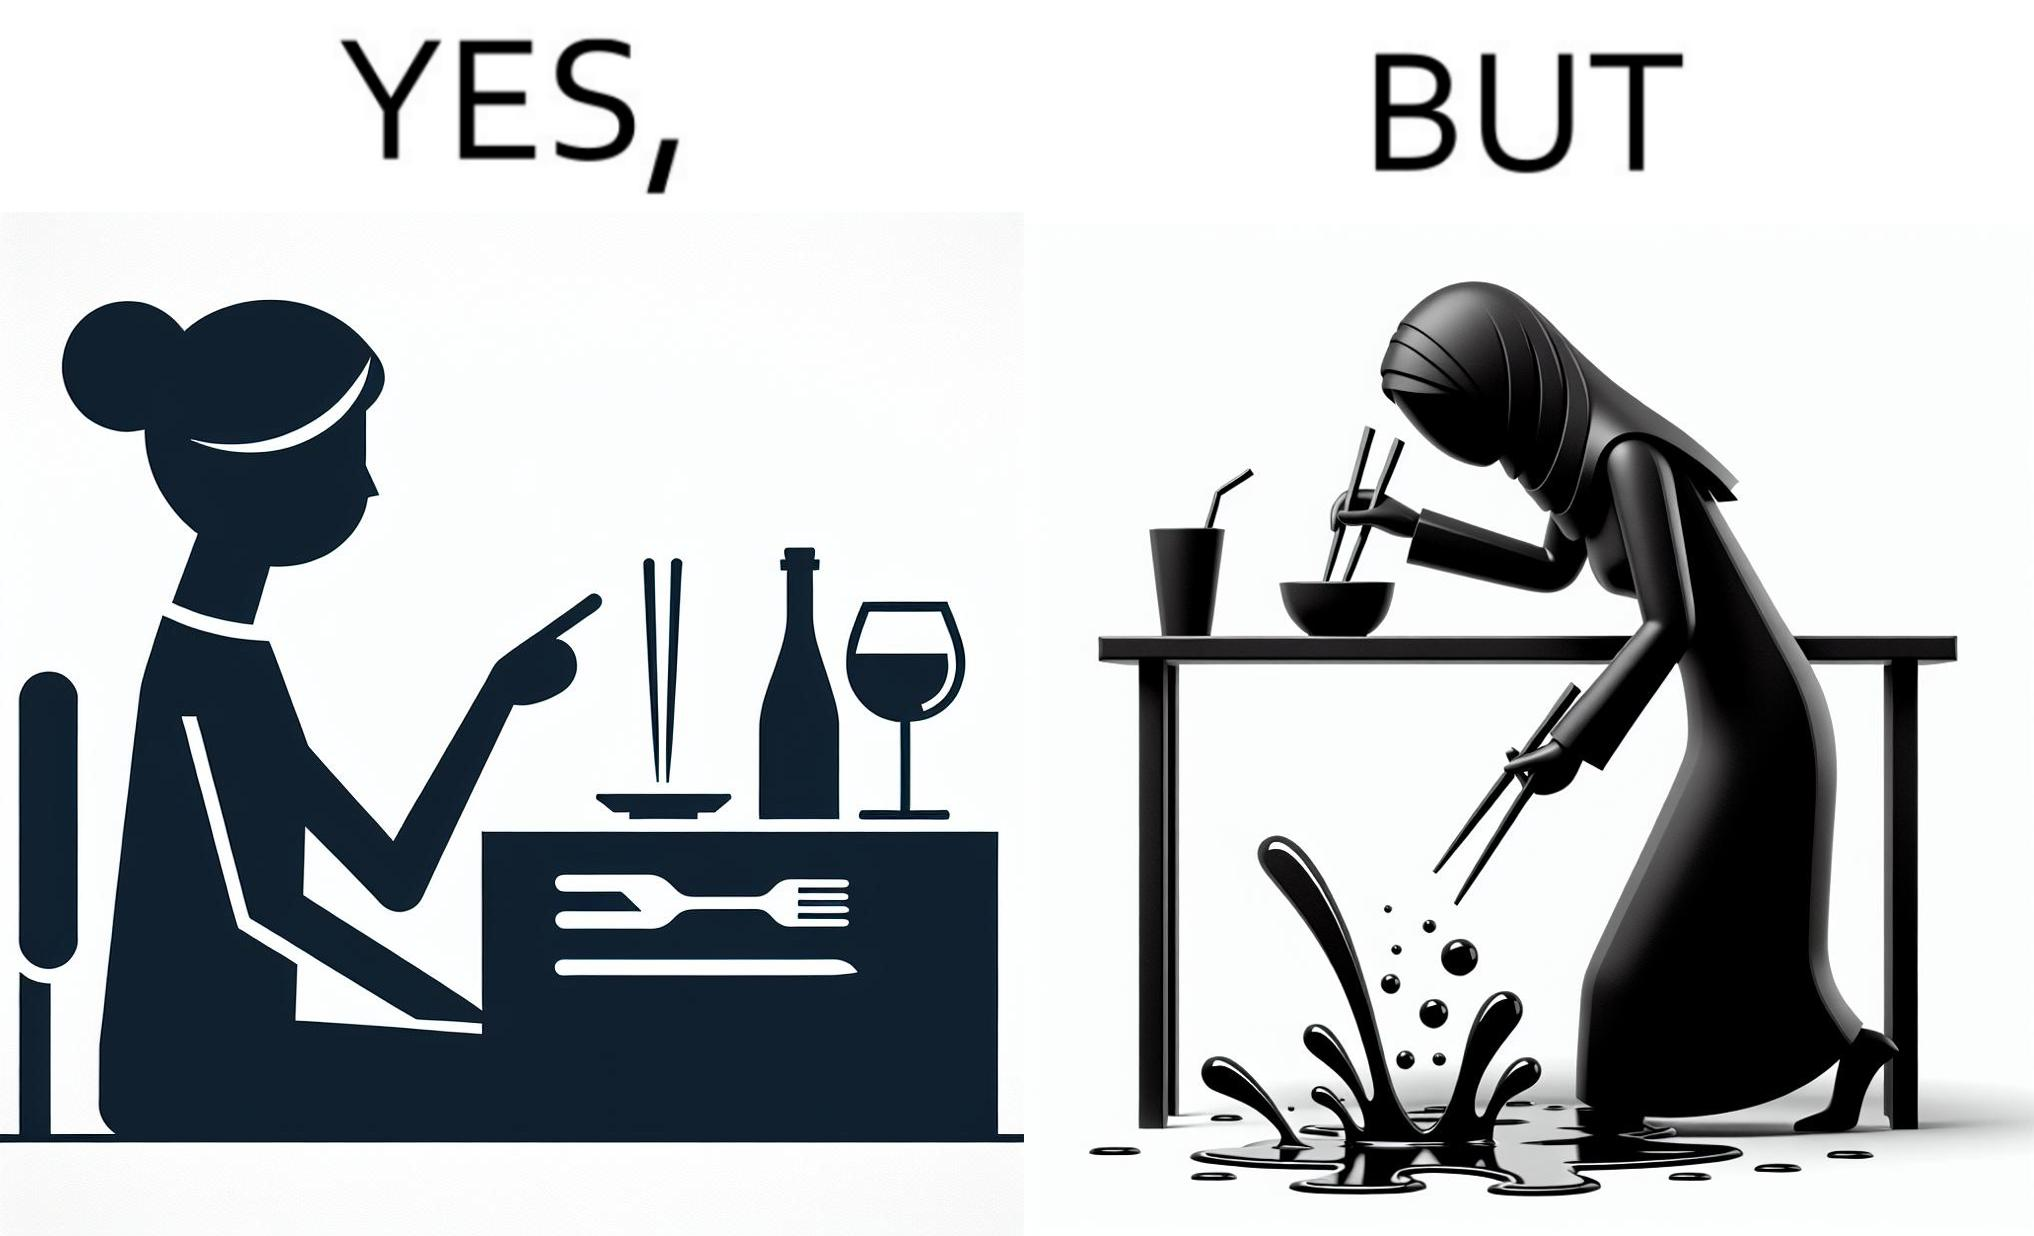Is there satirical content in this image? Yes, this image is satirical. 